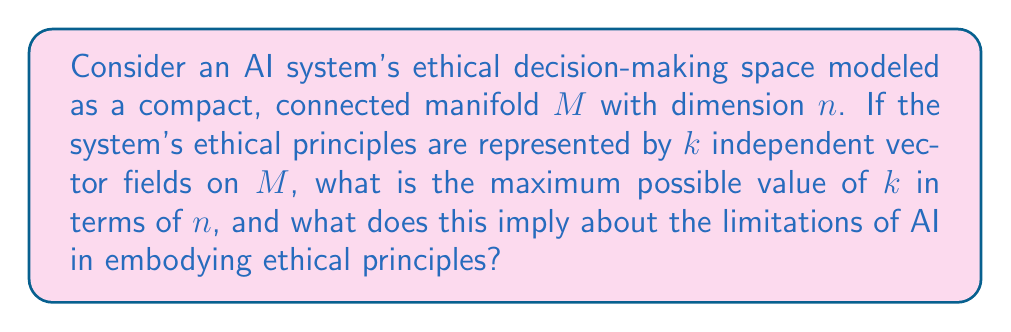Can you answer this question? To approach this problem, we need to consider the following steps:

1) First, recall the Hairy Ball Theorem, which states that there is no non-vanishing continuous tangent vector field on even-dimensional n-spheres. This theorem has implications for our problem.

2) The maximum number of independent vector fields on an n-dimensional manifold is related to the parallelizability of the manifold. A manifold is parallelizable if it admits $n$ linearly independent vector fields.

3) For a compact, connected manifold $M$ of dimension $n$, the maximum number of linearly independent vector fields $k$ is given by:

   $$k = \rho(n) - 1$$

   where $\rho(n)$ is the Radon-Hurwitz function defined as:

   $$\rho(n) = 2^c + 8d$$

   where $n = (2a+1)2^{4b+c}$ with $0 \leq c \leq 3$ and $d = 2^b$.

4) The Radon-Hurwitz function gives the following values for the first few dimensions:

   $$\rho(1) = 1, \rho(2) = 2, \rho(3) = 3, \rho(4) = 4, \rho(5) = 5, \rho(6) = 6, \rho(7) = 7, \rho(8) = 8, \rho(9) = 9$$

5) Therefore, the maximum number of independent vector fields $k$ for the first few dimensions are:

   $$k = 0, 1, 2, 3, 4, 5, 6, 7, 8$$ for $n = 1, 2, 3, 4, 5, 6, 7, 8, 9$ respectively.

6) This result implies that for any n-dimensional ethical decision-making space, there is an upper bound on the number of independent ethical principles (represented by vector fields) that can be consistently applied.

7) From a philosophical perspective, this mathematical limitation could be interpreted as a fundamental constraint on the ability of AI systems to embody a complete set of ethical principles. The number of ethical principles that can be consistently applied is limited by the dimensionality of the decision-making space.
Answer: The maximum possible value of $k$ (number of independent vector fields) for an n-dimensional manifold $M$ is $k = \rho(n) - 1$, where $\rho(n)$ is the Radon-Hurwitz function. This implies that AI systems have an inherent mathematical limitation in embodying ethical principles, as the number of consistent ethical principles is bounded by the dimensionality of the decision-making space. 